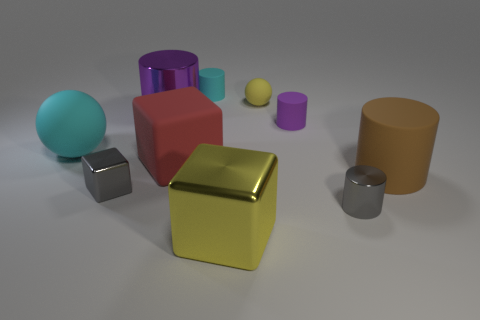Subtract 2 cylinders. How many cylinders are left? 3 Subtract all gray cylinders. How many cylinders are left? 4 Subtract all balls. How many objects are left? 8 Add 1 cyan cylinders. How many cyan cylinders are left? 2 Add 7 large red rubber cubes. How many large red rubber cubes exist? 8 Subtract 1 cyan cylinders. How many objects are left? 9 Subtract all metal cubes. Subtract all cyan matte spheres. How many objects are left? 7 